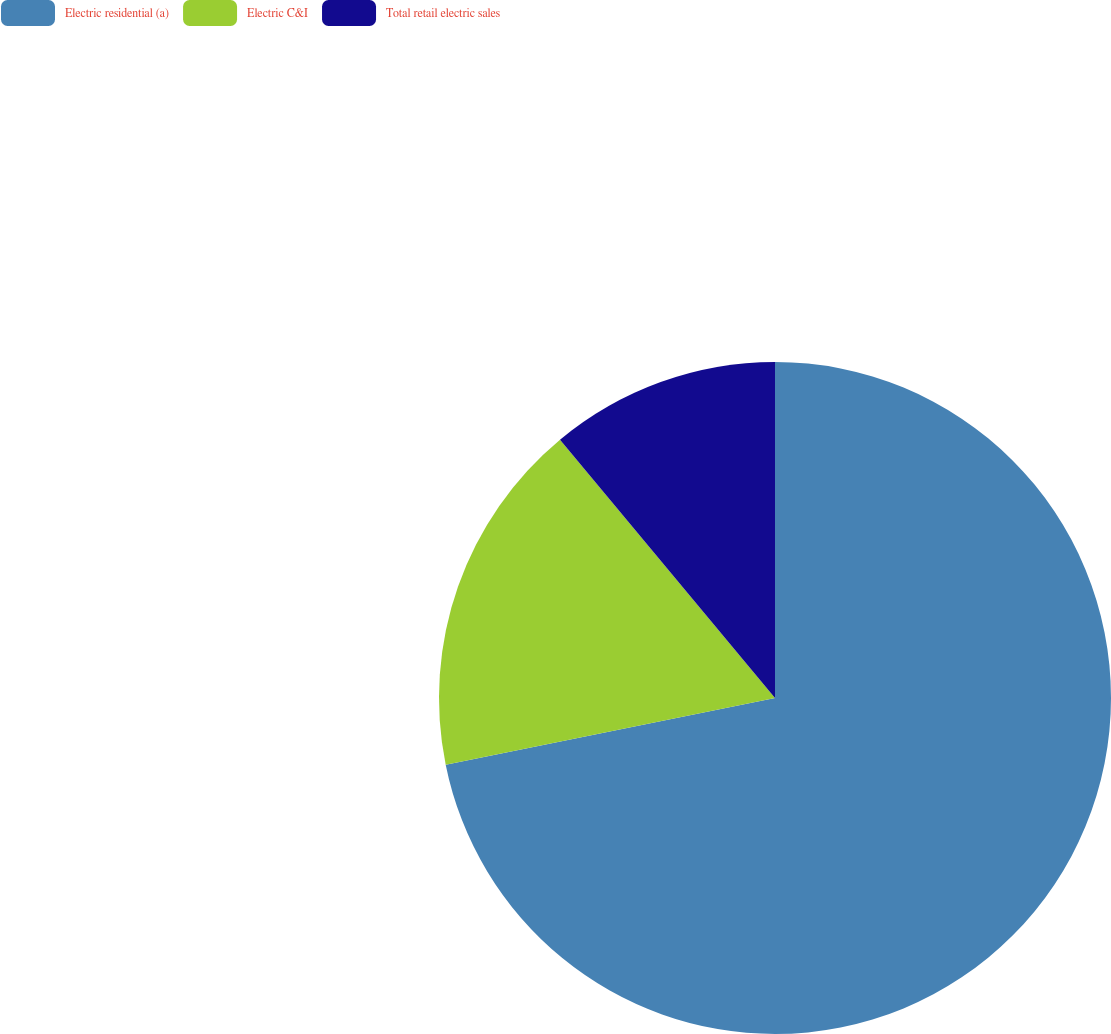<chart> <loc_0><loc_0><loc_500><loc_500><pie_chart><fcel>Electric residential (a)<fcel>Electric C&I<fcel>Total retail electric sales<nl><fcel>71.82%<fcel>17.13%<fcel>11.05%<nl></chart> 